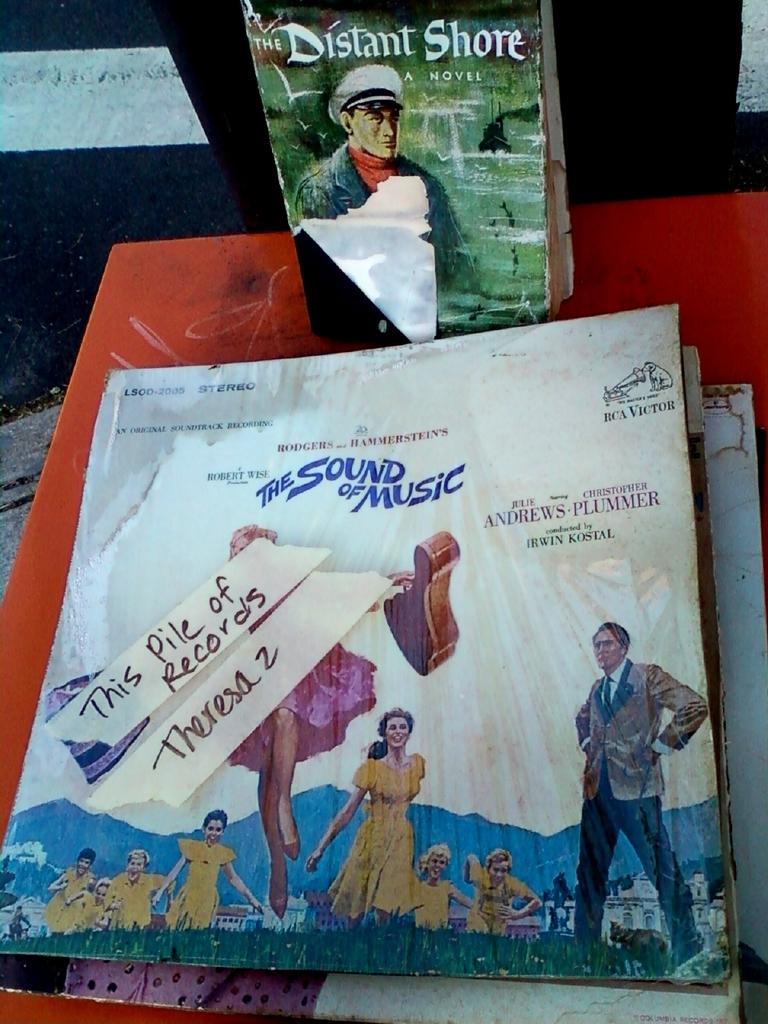Can you describe this image briefly? Here in this picture we can see music covers and books present on the table and on that we can see some people standing that are printed over there. 